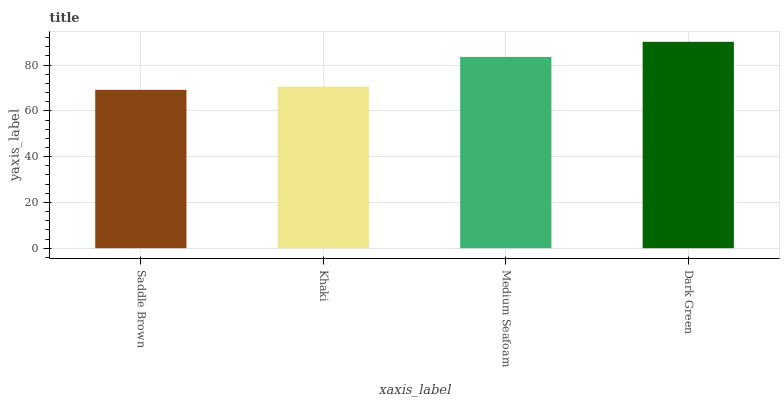Is Saddle Brown the minimum?
Answer yes or no. Yes. Is Dark Green the maximum?
Answer yes or no. Yes. Is Khaki the minimum?
Answer yes or no. No. Is Khaki the maximum?
Answer yes or no. No. Is Khaki greater than Saddle Brown?
Answer yes or no. Yes. Is Saddle Brown less than Khaki?
Answer yes or no. Yes. Is Saddle Brown greater than Khaki?
Answer yes or no. No. Is Khaki less than Saddle Brown?
Answer yes or no. No. Is Medium Seafoam the high median?
Answer yes or no. Yes. Is Khaki the low median?
Answer yes or no. Yes. Is Khaki the high median?
Answer yes or no. No. Is Saddle Brown the low median?
Answer yes or no. No. 